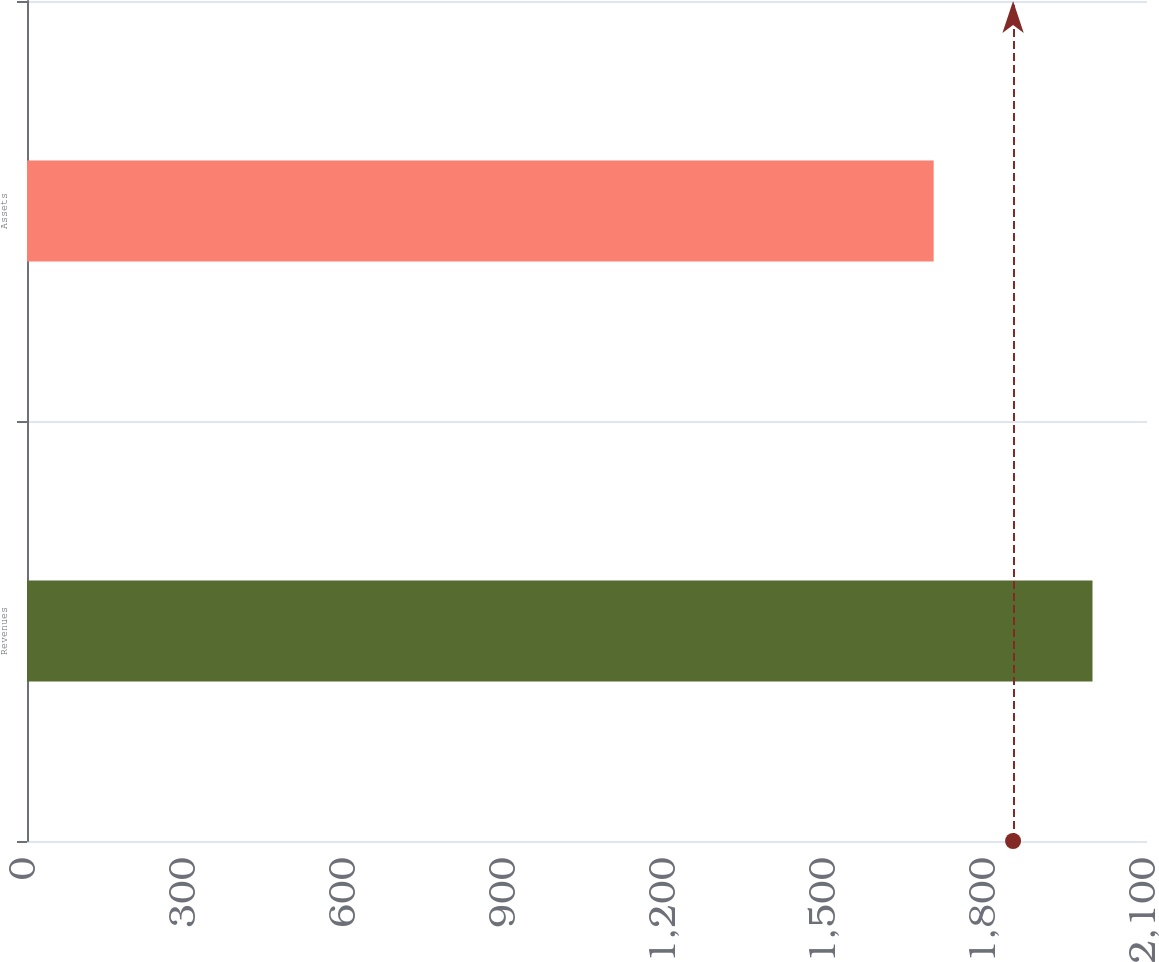<chart> <loc_0><loc_0><loc_500><loc_500><bar_chart><fcel>Revenues<fcel>Assets<nl><fcel>1997.8<fcel>1700<nl></chart> 